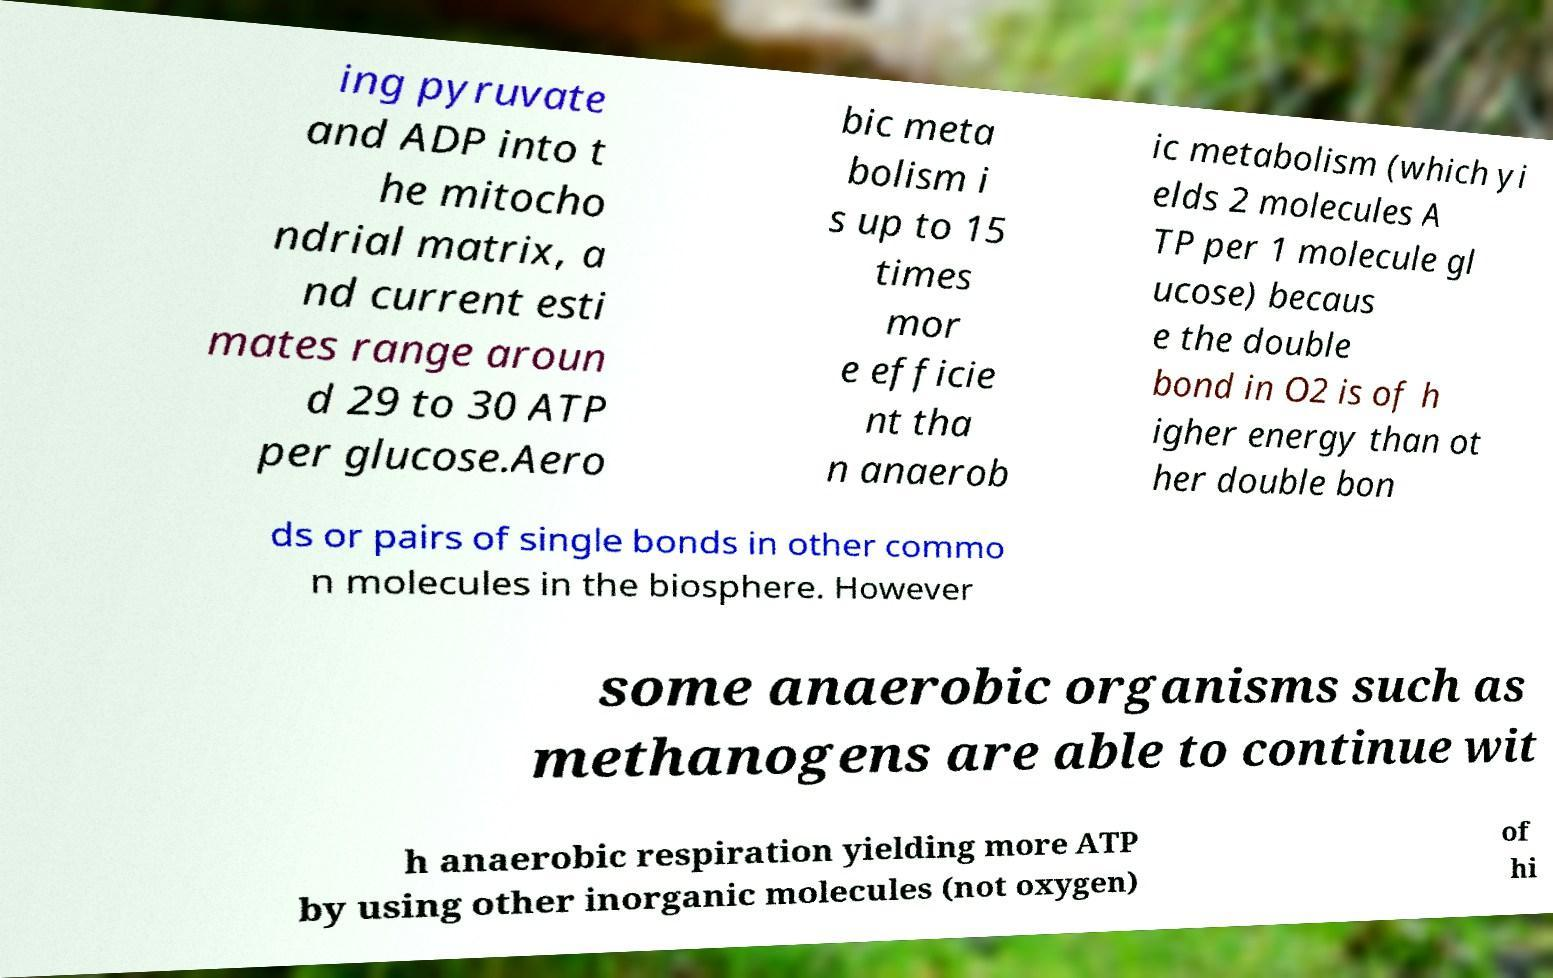Please identify and transcribe the text found in this image. ing pyruvate and ADP into t he mitocho ndrial matrix, a nd current esti mates range aroun d 29 to 30 ATP per glucose.Aero bic meta bolism i s up to 15 times mor e efficie nt tha n anaerob ic metabolism (which yi elds 2 molecules A TP per 1 molecule gl ucose) becaus e the double bond in O2 is of h igher energy than ot her double bon ds or pairs of single bonds in other commo n molecules in the biosphere. However some anaerobic organisms such as methanogens are able to continue wit h anaerobic respiration yielding more ATP by using other inorganic molecules (not oxygen) of hi 